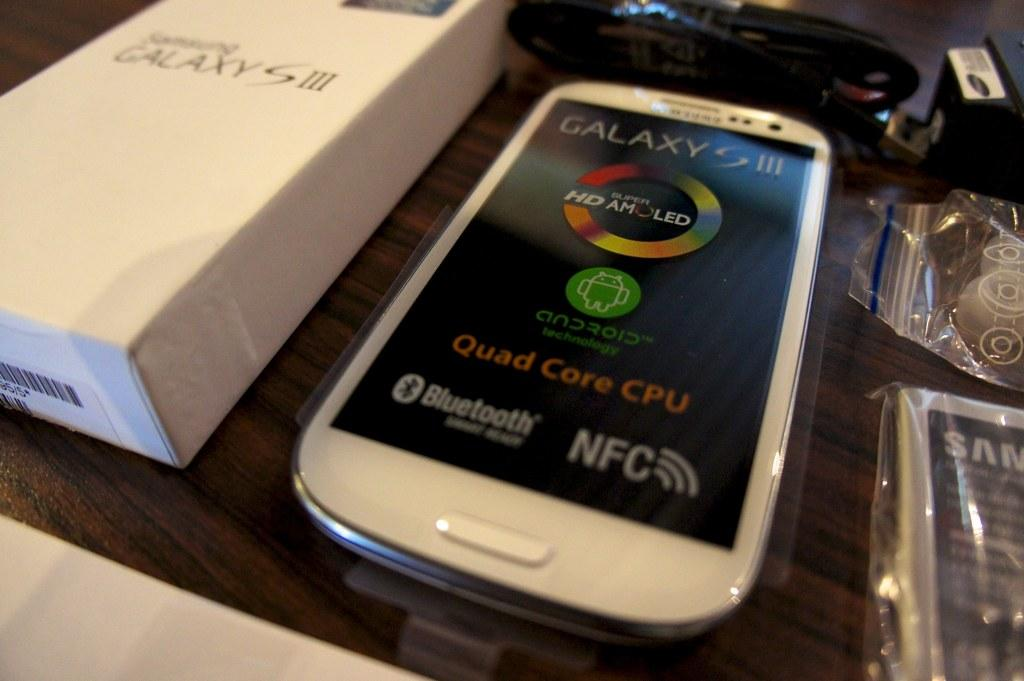Provide a one-sentence caption for the provided image. The all new Galaxy S 3, comes in a pretty white along with the box can be yours today. 